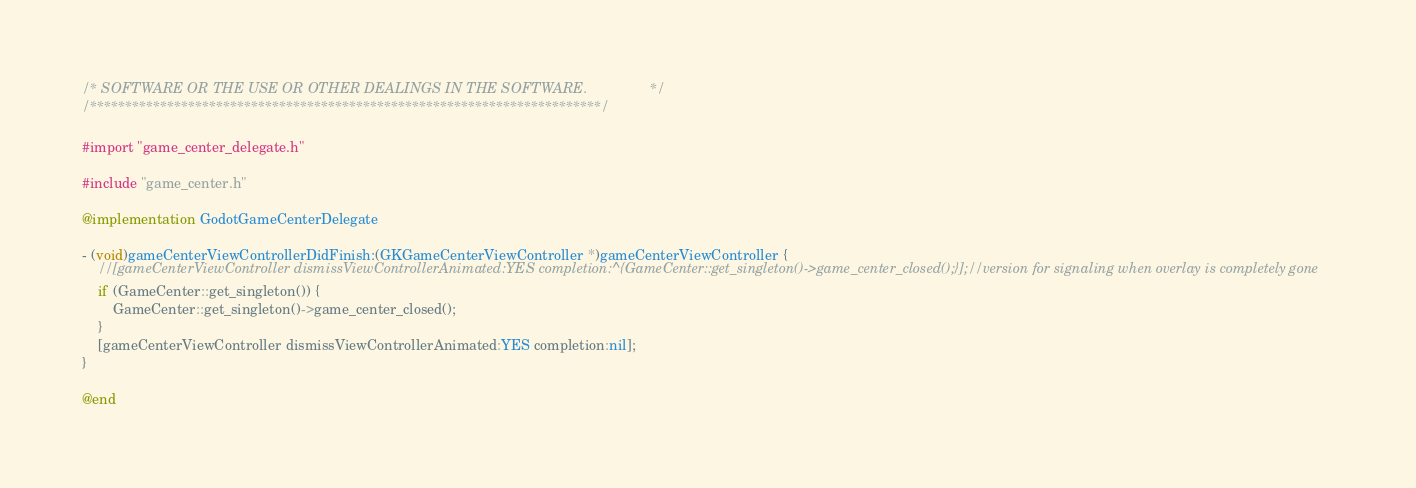<code> <loc_0><loc_0><loc_500><loc_500><_ObjectiveC_>/* SOFTWARE OR THE USE OR OTHER DEALINGS IN THE SOFTWARE.                */
/*************************************************************************/

#import "game_center_delegate.h"

#include "game_center.h"

@implementation GodotGameCenterDelegate

- (void)gameCenterViewControllerDidFinish:(GKGameCenterViewController *)gameCenterViewController {
	//[gameCenterViewController dismissViewControllerAnimated:YES completion:^{GameCenter::get_singleton()->game_center_closed();}];//version for signaling when overlay is completely gone
	if (GameCenter::get_singleton()) {
		GameCenter::get_singleton()->game_center_closed();
	}
	[gameCenterViewController dismissViewControllerAnimated:YES completion:nil];
}

@end
</code> 